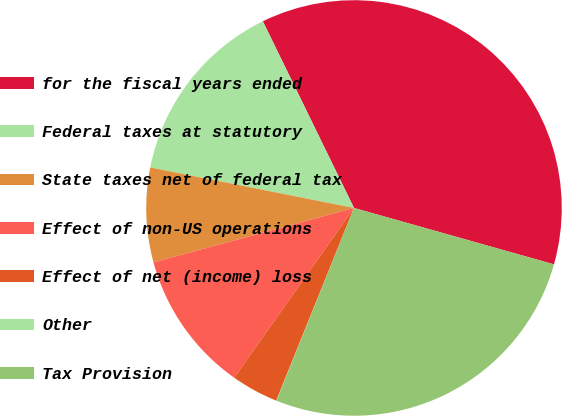Convert chart. <chart><loc_0><loc_0><loc_500><loc_500><pie_chart><fcel>for the fiscal years ended<fcel>Federal taxes at statutory<fcel>State taxes net of federal tax<fcel>Effect of non-US operations<fcel>Effect of net (income) loss<fcel>Other<fcel>Tax Provision<nl><fcel>36.61%<fcel>14.65%<fcel>7.34%<fcel>11.0%<fcel>3.68%<fcel>0.02%<fcel>26.71%<nl></chart> 